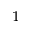Convert formula to latex. <formula><loc_0><loc_0><loc_500><loc_500>^ { 1 }</formula> 